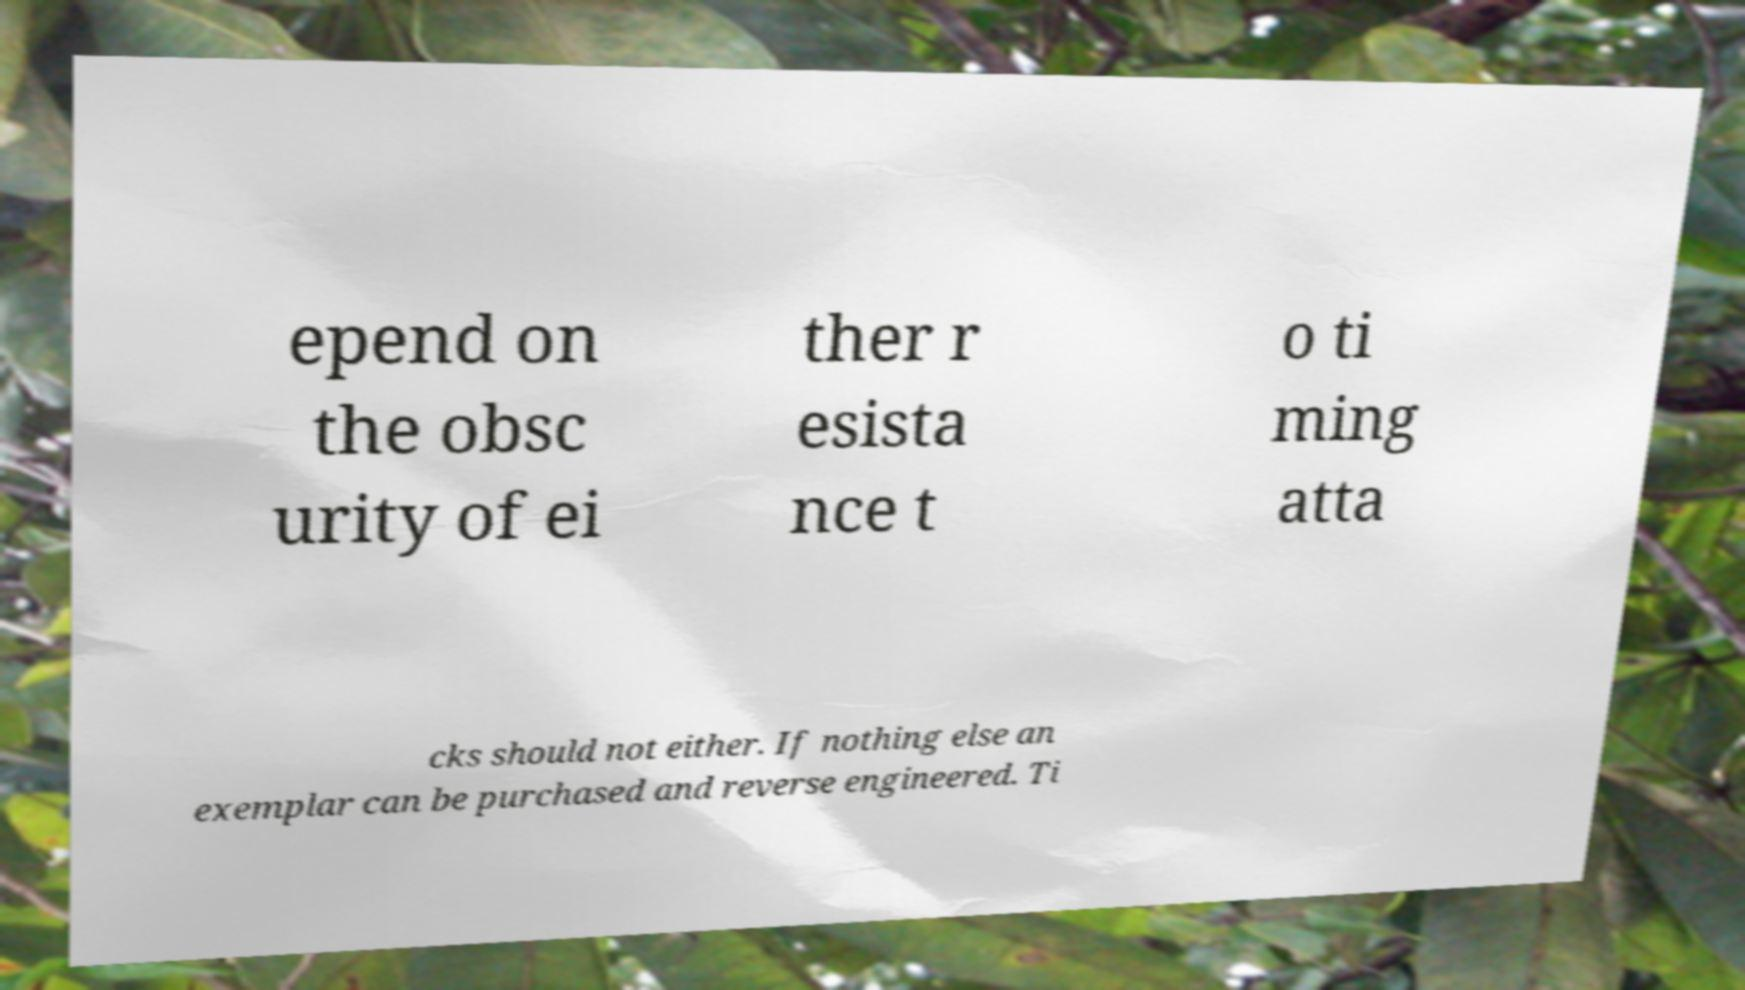Could you assist in decoding the text presented in this image and type it out clearly? epend on the obsc urity of ei ther r esista nce t o ti ming atta cks should not either. If nothing else an exemplar can be purchased and reverse engineered. Ti 